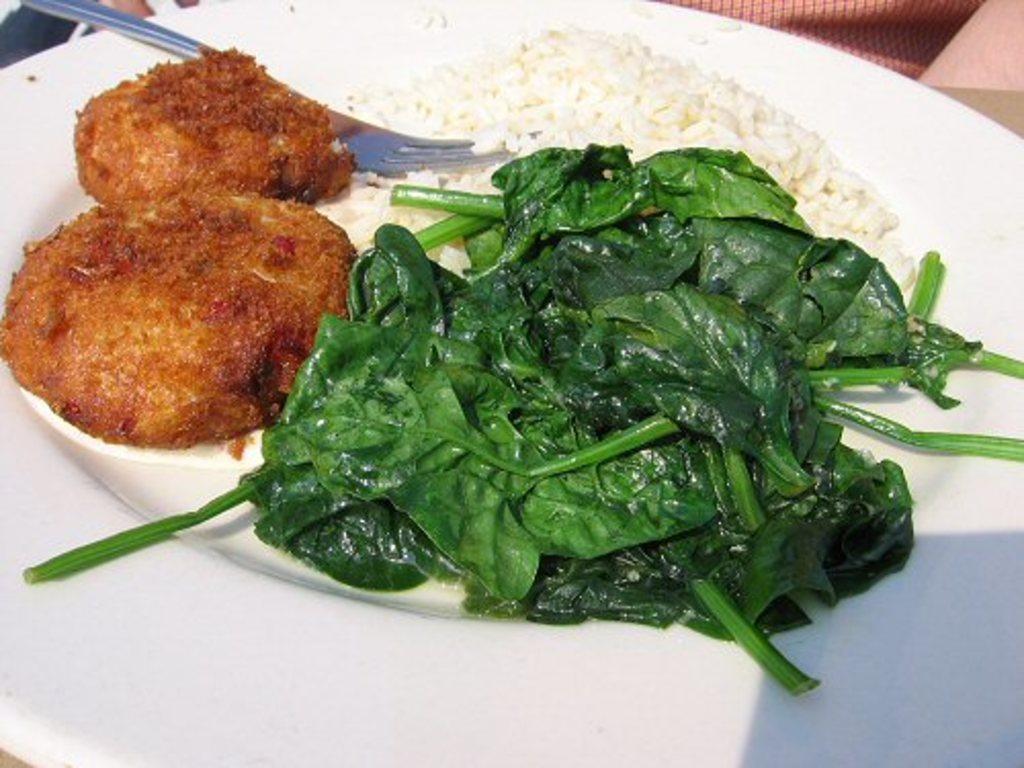Describe this image in one or two sentences. In this image there is a plate with rice, a fork, spinach and two nuggets on it. At the top of the image there is a person. 